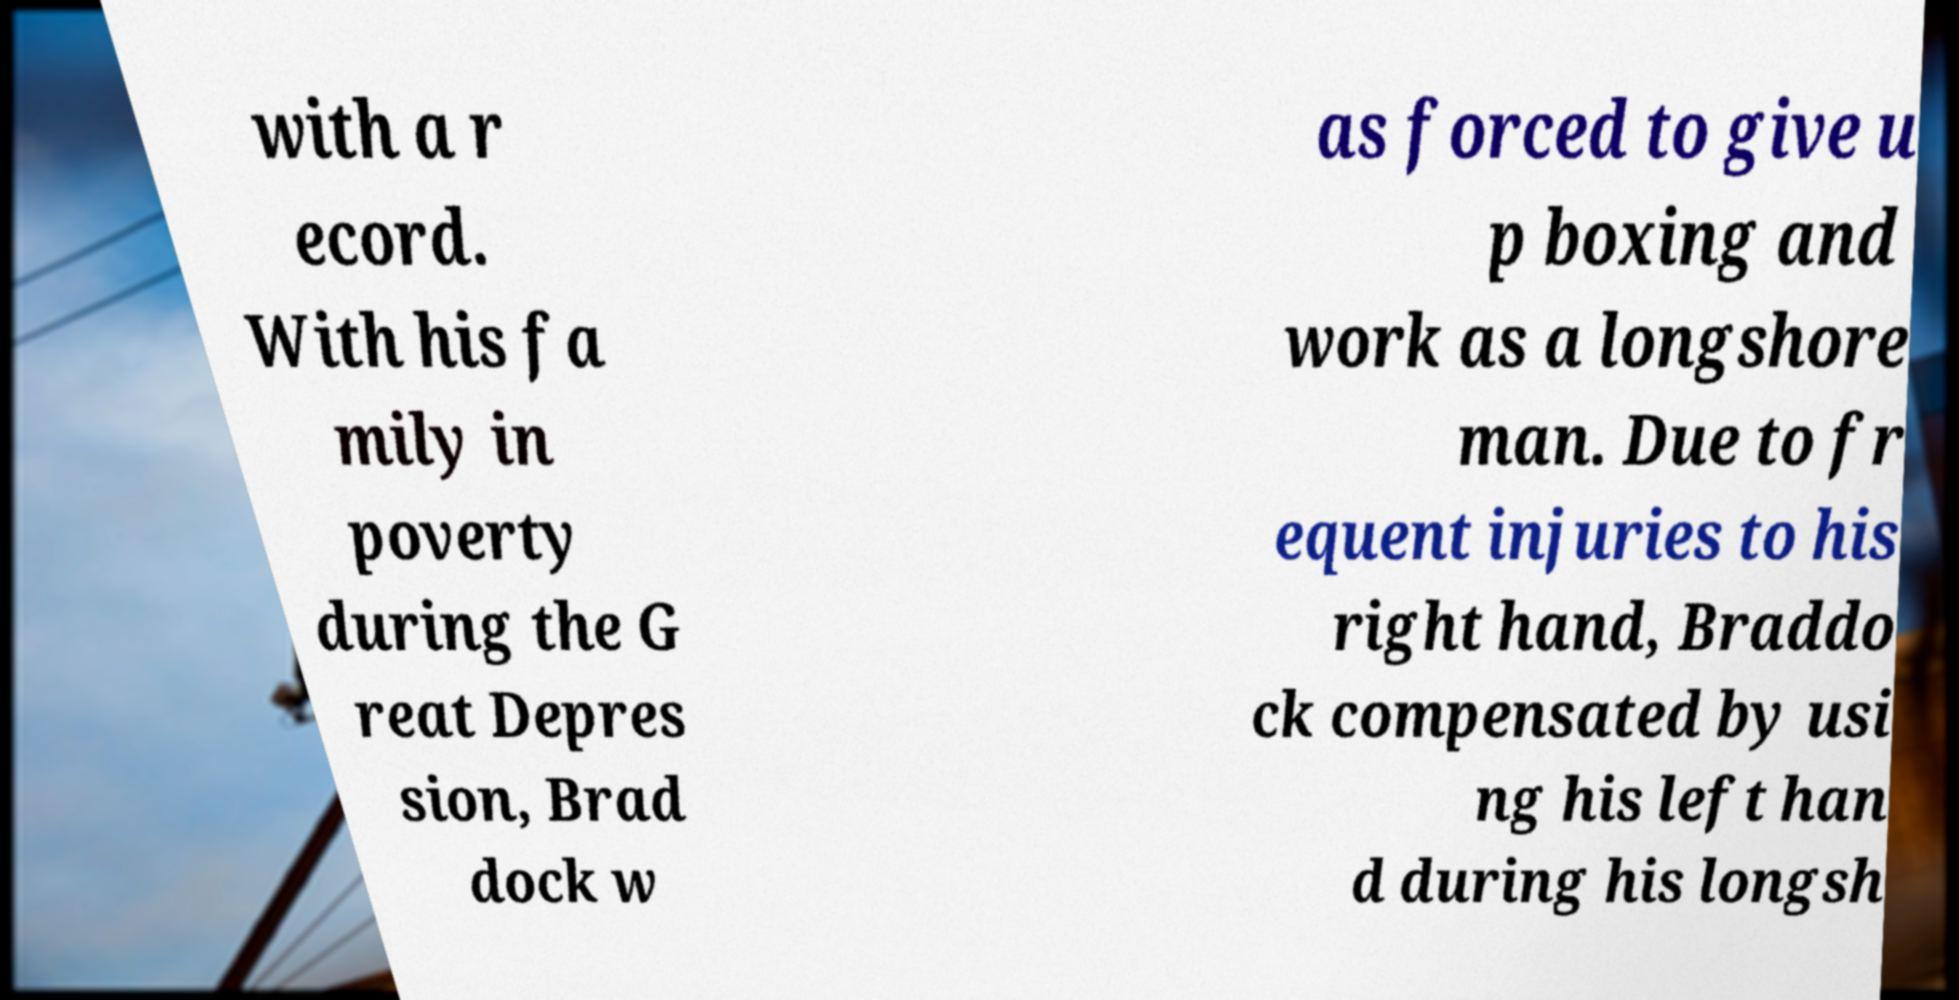Please read and relay the text visible in this image. What does it say? with a r ecord. With his fa mily in poverty during the G reat Depres sion, Brad dock w as forced to give u p boxing and work as a longshore man. Due to fr equent injuries to his right hand, Braddo ck compensated by usi ng his left han d during his longsh 